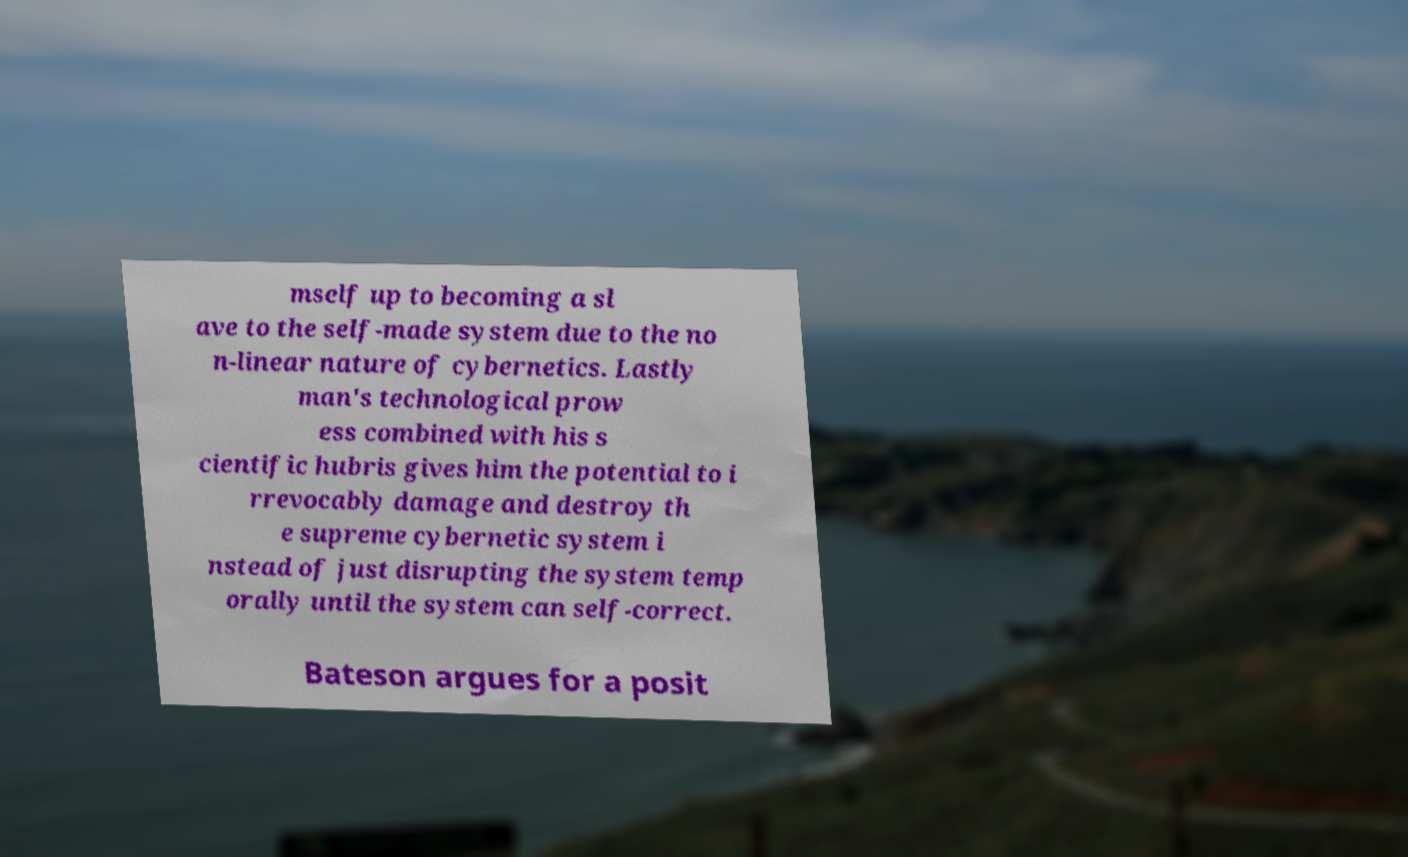I need the written content from this picture converted into text. Can you do that? mself up to becoming a sl ave to the self-made system due to the no n-linear nature of cybernetics. Lastly man's technological prow ess combined with his s cientific hubris gives him the potential to i rrevocably damage and destroy th e supreme cybernetic system i nstead of just disrupting the system temp orally until the system can self-correct. Bateson argues for a posit 